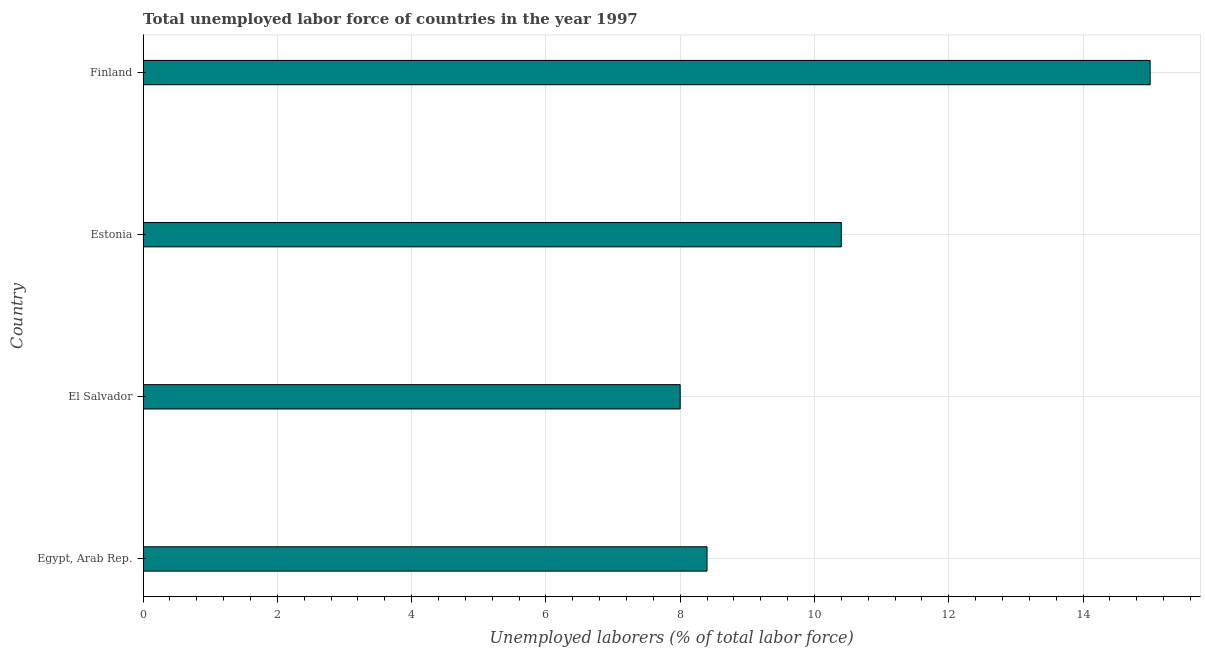Does the graph contain any zero values?
Offer a very short reply. No. Does the graph contain grids?
Make the answer very short. Yes. What is the title of the graph?
Offer a terse response. Total unemployed labor force of countries in the year 1997. What is the label or title of the X-axis?
Offer a very short reply. Unemployed laborers (% of total labor force). What is the label or title of the Y-axis?
Make the answer very short. Country. What is the total unemployed labour force in El Salvador?
Your response must be concise. 8. In which country was the total unemployed labour force maximum?
Provide a short and direct response. Finland. In which country was the total unemployed labour force minimum?
Offer a terse response. El Salvador. What is the sum of the total unemployed labour force?
Your answer should be compact. 41.8. What is the difference between the total unemployed labour force in El Salvador and Estonia?
Your answer should be compact. -2.4. What is the average total unemployed labour force per country?
Your response must be concise. 10.45. What is the median total unemployed labour force?
Provide a succinct answer. 9.4. In how many countries, is the total unemployed labour force greater than 12.4 %?
Keep it short and to the point. 1. What is the ratio of the total unemployed labour force in El Salvador to that in Estonia?
Ensure brevity in your answer.  0.77. What is the difference between the highest and the second highest total unemployed labour force?
Ensure brevity in your answer.  4.6. Is the sum of the total unemployed labour force in Egypt, Arab Rep. and Finland greater than the maximum total unemployed labour force across all countries?
Ensure brevity in your answer.  Yes. What is the difference between the highest and the lowest total unemployed labour force?
Your response must be concise. 7. Are all the bars in the graph horizontal?
Ensure brevity in your answer.  Yes. What is the difference between two consecutive major ticks on the X-axis?
Your answer should be very brief. 2. What is the Unemployed laborers (% of total labor force) of Egypt, Arab Rep.?
Your response must be concise. 8.4. What is the Unemployed laborers (% of total labor force) in El Salvador?
Ensure brevity in your answer.  8. What is the Unemployed laborers (% of total labor force) in Estonia?
Your response must be concise. 10.4. What is the Unemployed laborers (% of total labor force) in Finland?
Provide a short and direct response. 15. What is the difference between the Unemployed laborers (% of total labor force) in Egypt, Arab Rep. and El Salvador?
Your answer should be very brief. 0.4. What is the difference between the Unemployed laborers (% of total labor force) in Egypt, Arab Rep. and Finland?
Offer a terse response. -6.6. What is the difference between the Unemployed laborers (% of total labor force) in El Salvador and Estonia?
Your answer should be compact. -2.4. What is the ratio of the Unemployed laborers (% of total labor force) in Egypt, Arab Rep. to that in El Salvador?
Provide a succinct answer. 1.05. What is the ratio of the Unemployed laborers (% of total labor force) in Egypt, Arab Rep. to that in Estonia?
Your answer should be compact. 0.81. What is the ratio of the Unemployed laborers (% of total labor force) in Egypt, Arab Rep. to that in Finland?
Your answer should be compact. 0.56. What is the ratio of the Unemployed laborers (% of total labor force) in El Salvador to that in Estonia?
Your answer should be very brief. 0.77. What is the ratio of the Unemployed laborers (% of total labor force) in El Salvador to that in Finland?
Provide a short and direct response. 0.53. What is the ratio of the Unemployed laborers (% of total labor force) in Estonia to that in Finland?
Provide a short and direct response. 0.69. 